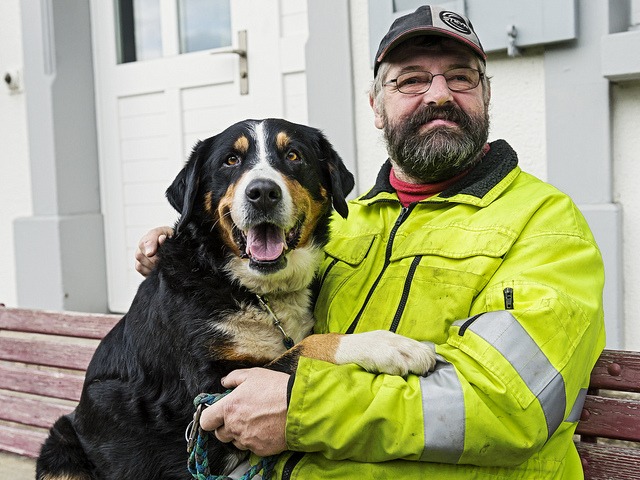<image>What breed is the dog? I don't know what breed the dog is. It can be a collie, lab, retriever, shepherd, draft, burmese mountain dog or a mixed breed. What breed is the dog? I don't know what breed the dog is. It can be any of the mentioned breeds. 